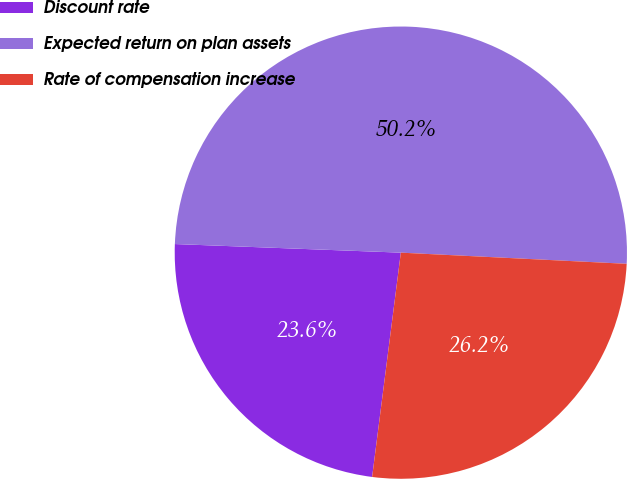<chart> <loc_0><loc_0><loc_500><loc_500><pie_chart><fcel>Discount rate<fcel>Expected return on plan assets<fcel>Rate of compensation increase<nl><fcel>23.58%<fcel>50.18%<fcel>26.24%<nl></chart> 